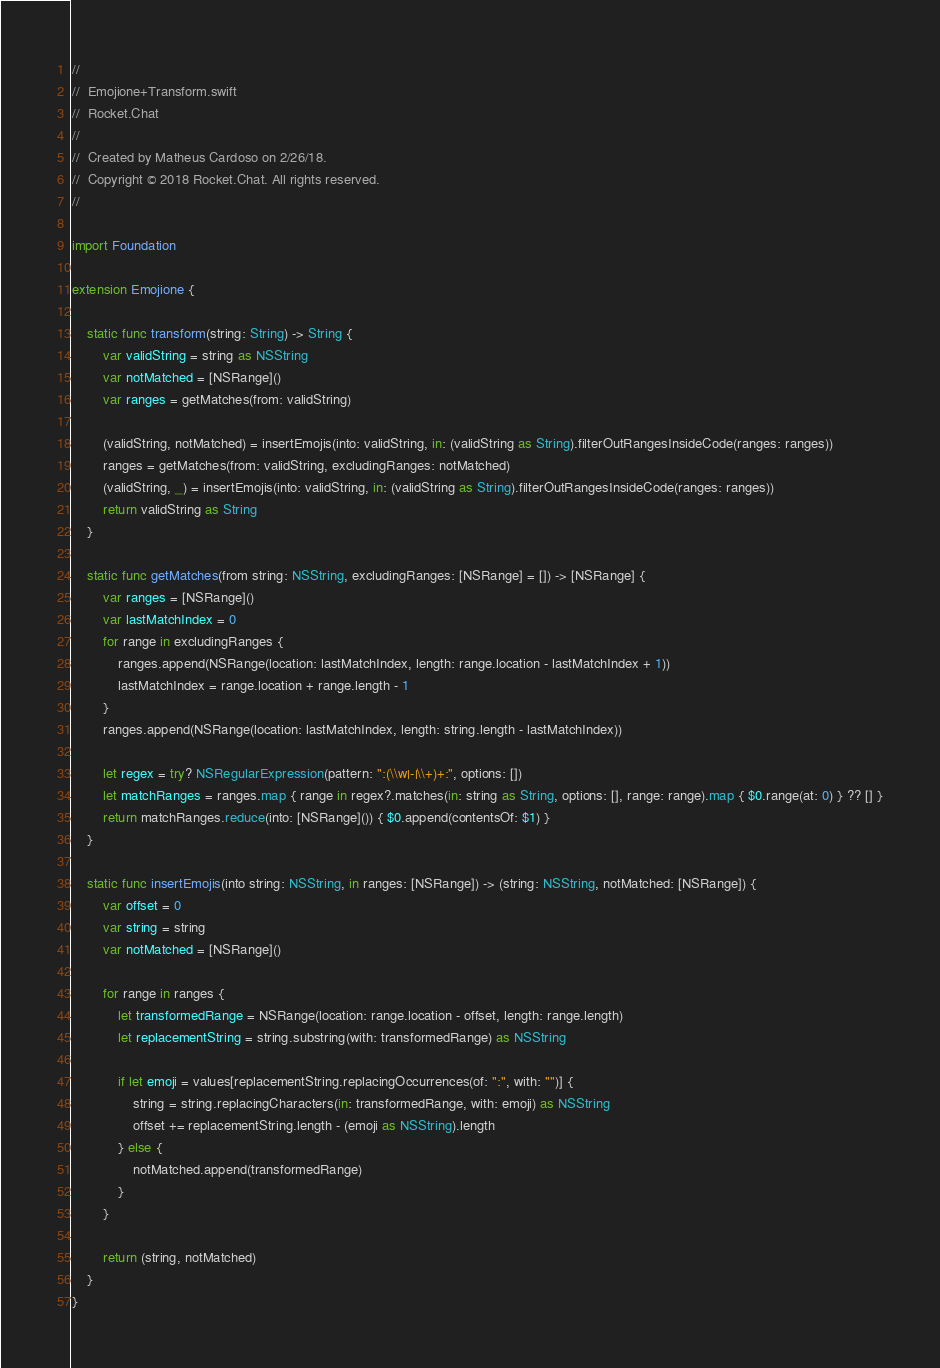<code> <loc_0><loc_0><loc_500><loc_500><_Swift_>//
//  Emojione+Transform.swift
//  Rocket.Chat
//
//  Created by Matheus Cardoso on 2/26/18.
//  Copyright © 2018 Rocket.Chat. All rights reserved.
//

import Foundation

extension Emojione {

    static func transform(string: String) -> String {
        var validString = string as NSString
        var notMatched = [NSRange]()
        var ranges = getMatches(from: validString)

        (validString, notMatched) = insertEmojis(into: validString, in: (validString as String).filterOutRangesInsideCode(ranges: ranges))
        ranges = getMatches(from: validString, excludingRanges: notMatched)
        (validString, _) = insertEmojis(into: validString, in: (validString as String).filterOutRangesInsideCode(ranges: ranges))
        return validString as String
    }

    static func getMatches(from string: NSString, excludingRanges: [NSRange] = []) -> [NSRange] {
        var ranges = [NSRange]()
        var lastMatchIndex = 0
        for range in excludingRanges {
            ranges.append(NSRange(location: lastMatchIndex, length: range.location - lastMatchIndex + 1))
            lastMatchIndex = range.location + range.length - 1
        }
        ranges.append(NSRange(location: lastMatchIndex, length: string.length - lastMatchIndex))

        let regex = try? NSRegularExpression(pattern: ":(\\w|-|\\+)+:", options: [])
        let matchRanges = ranges.map { range in regex?.matches(in: string as String, options: [], range: range).map { $0.range(at: 0) } ?? [] }
        return matchRanges.reduce(into: [NSRange]()) { $0.append(contentsOf: $1) }
    }

    static func insertEmojis(into string: NSString, in ranges: [NSRange]) -> (string: NSString, notMatched: [NSRange]) {
        var offset = 0
        var string = string
        var notMatched = [NSRange]()

        for range in ranges {
            let transformedRange = NSRange(location: range.location - offset, length: range.length)
            let replacementString = string.substring(with: transformedRange) as NSString

            if let emoji = values[replacementString.replacingOccurrences(of: ":", with: "")] {
                string = string.replacingCharacters(in: transformedRange, with: emoji) as NSString
                offset += replacementString.length - (emoji as NSString).length
            } else {
                notMatched.append(transformedRange)
            }
        }

        return (string, notMatched)
    }
}
</code> 